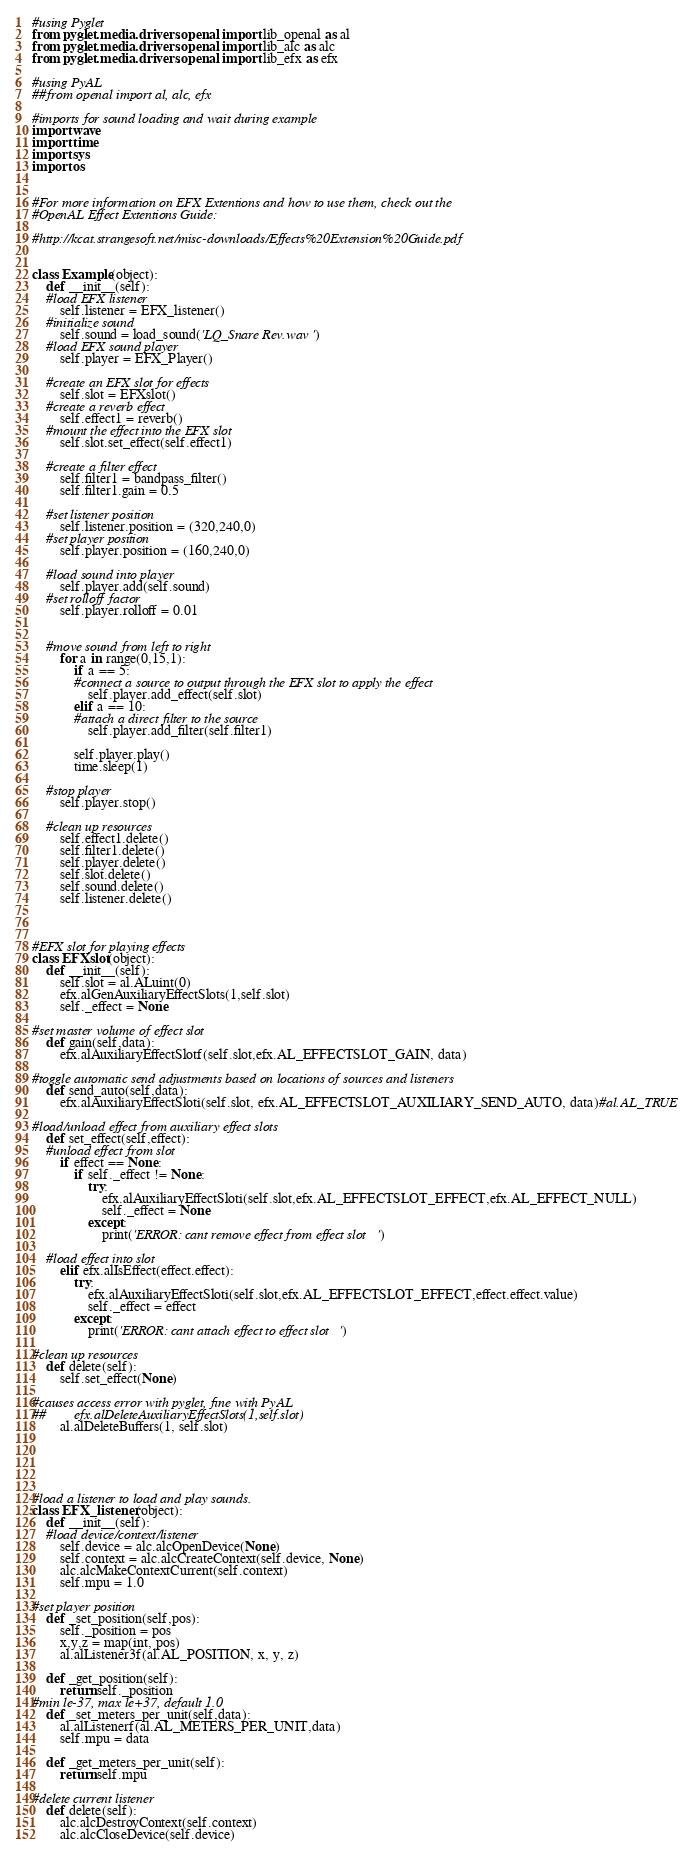Convert code to text. <code><loc_0><loc_0><loc_500><loc_500><_Python_>#using Pyglet
from pyglet.media.drivers.openal import lib_openal as al
from pyglet.media.drivers.openal import lib_alc as alc
from pyglet.media.drivers.openal import lib_efx as efx

#using PyAL
##from openal import al, alc, efx

#imports for sound loading and wait during example
import wave
import time
import sys
import os


#For more information on EFX Extentions and how to use them, check out the
#OpenAL Effect Extentions Guide:

#http://kcat.strangesoft.net/misc-downloads/Effects%20Extension%20Guide.pdf


class Example(object):
    def __init__(self):
    #load EFX listener
        self.listener = EFX_listener()
    #initialize sound
        self.sound = load_sound('LQ_Snare Rev.wav')
    #load EFX sound player
        self.player = EFX_Player()

    #create an EFX slot for effects
        self.slot = EFXslot()
    #create a reverb effect
        self.effect1 = reverb()
    #mount the effect into the EFX slot
        self.slot.set_effect(self.effect1)

    #create a filter effect
        self.filter1 = bandpass_filter()
        self.filter1.gain = 0.5
        
    #set listener position
        self.listener.position = (320,240,0)
    #set player position
        self.player.position = (160,240,0)

    #load sound into player
        self.player.add(self.sound)
    #set rolloff factor
        self.player.rolloff = 0.01


    #move sound from left to right
        for a in range(0,15,1):
            if a == 5:
            #connect a source to output through the EFX slot to apply the effect
                self.player.add_effect(self.slot)
            elif a == 10:
            #attach a direct filter to the source
                self.player.add_filter(self.filter1)

            self.player.play()
            time.sleep(1)

    #stop player
        self.player.stop()

    #clean up resources
        self.effect1.delete()
        self.filter1.delete()
        self.player.delete()
        self.slot.delete()
        self.sound.delete()
        self.listener.delete()
        


#EFX slot for playing effects
class EFXslot(object):
    def __init__(self):
        self.slot = al.ALuint(0)
        efx.alGenAuxiliaryEffectSlots(1,self.slot)
        self._effect = None

#set master volume of effect slot
    def gain(self,data):
        efx.alAuxiliaryEffectSlotf(self.slot,efx.AL_EFFECTSLOT_GAIN, data)

#toggle automatic send adjustments based on locations of sources and listeners
    def send_auto(self,data):
        efx.alAuxiliaryEffectSloti(self.slot, efx.AL_EFFECTSLOT_AUXILIARY_SEND_AUTO, data)#al.AL_TRUE

#load/unload effect from auxiliary effect slots
    def set_effect(self,effect):
    #unload effect from slot
        if effect == None:
            if self._effect != None:
                try:
                    efx.alAuxiliaryEffectSloti(self.slot,efx.AL_EFFECTSLOT_EFFECT,efx.AL_EFFECT_NULL)
                    self._effect = None
                except:
                    print('ERROR: cant remove effect from effect slot')

    #load effect into slot
        elif efx.alIsEffect(effect.effect):
            try:
                efx.alAuxiliaryEffectSloti(self.slot,efx.AL_EFFECTSLOT_EFFECT,effect.effect.value)
                self._effect = effect
            except:
                print('ERROR: cant attach effect to effect slot')

#clean up resources
    def delete(self):
        self.set_effect(None)

#causes access error with pyglet, fine with PyAL
##        efx.alDeleteAuxiliaryEffectSlots(1,self.slot)
        al.alDeleteBuffers(1, self.slot)





#load a listener to load and play sounds.
class EFX_listener(object):
    def __init__(self):
    #load device/context/listener
        self.device = alc.alcOpenDevice(None)
        self.context = alc.alcCreateContext(self.device, None)
        alc.alcMakeContextCurrent(self.context)
        self.mpu = 1.0

#set player position
    def _set_position(self,pos):
        self._position = pos
        x,y,z = map(int, pos)
        al.alListener3f(al.AL_POSITION, x, y, z)

    def _get_position(self):
        return self._position
#min le-37, max le+37, default 1.0
    def _set_meters_per_unit(self,data):
        al.alListenerf(al.AL_METERS_PER_UNIT,data)
        self.mpu = data

    def _get_meters_per_unit(self):
        return self.mpu

#delete current listener
    def delete(self):
        alc.alcDestroyContext(self.context)
        alc.alcCloseDevice(self.device)
</code> 